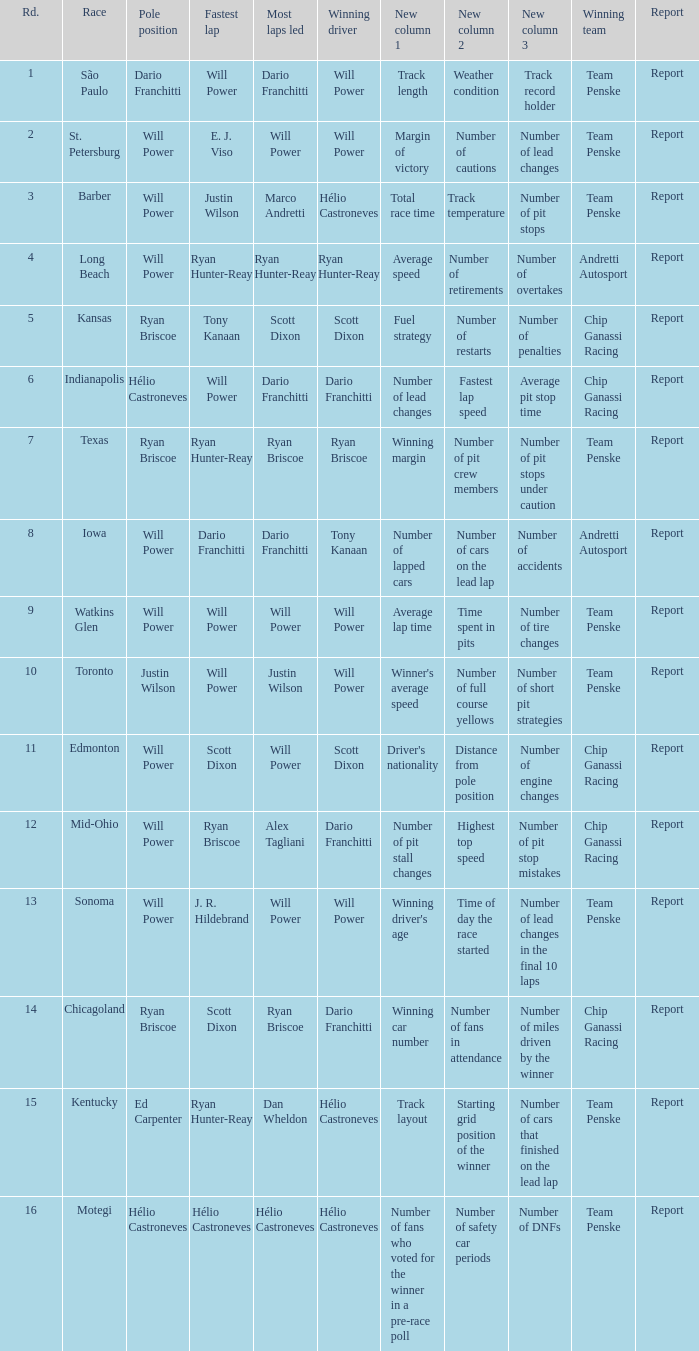What is the report for races where Will Power had both pole position and fastest lap? Report. 